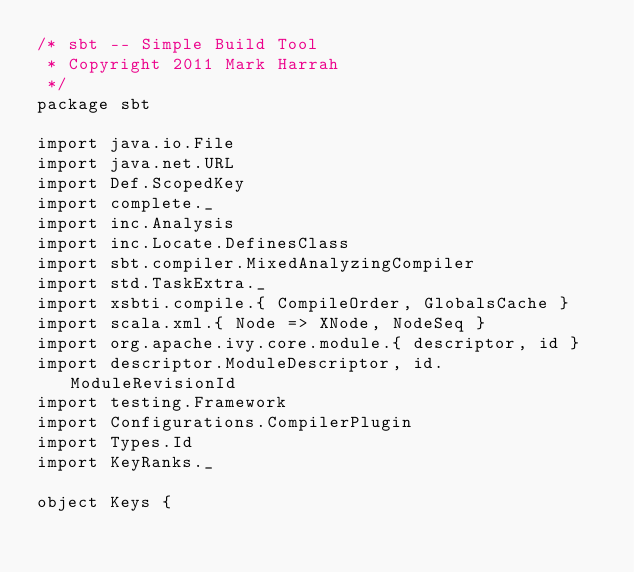<code> <loc_0><loc_0><loc_500><loc_500><_Scala_>/* sbt -- Simple Build Tool
 * Copyright 2011 Mark Harrah
 */
package sbt

import java.io.File
import java.net.URL
import Def.ScopedKey
import complete._
import inc.Analysis
import inc.Locate.DefinesClass
import sbt.compiler.MixedAnalyzingCompiler
import std.TaskExtra._
import xsbti.compile.{ CompileOrder, GlobalsCache }
import scala.xml.{ Node => XNode, NodeSeq }
import org.apache.ivy.core.module.{ descriptor, id }
import descriptor.ModuleDescriptor, id.ModuleRevisionId
import testing.Framework
import Configurations.CompilerPlugin
import Types.Id
import KeyRanks._

object Keys {</code> 